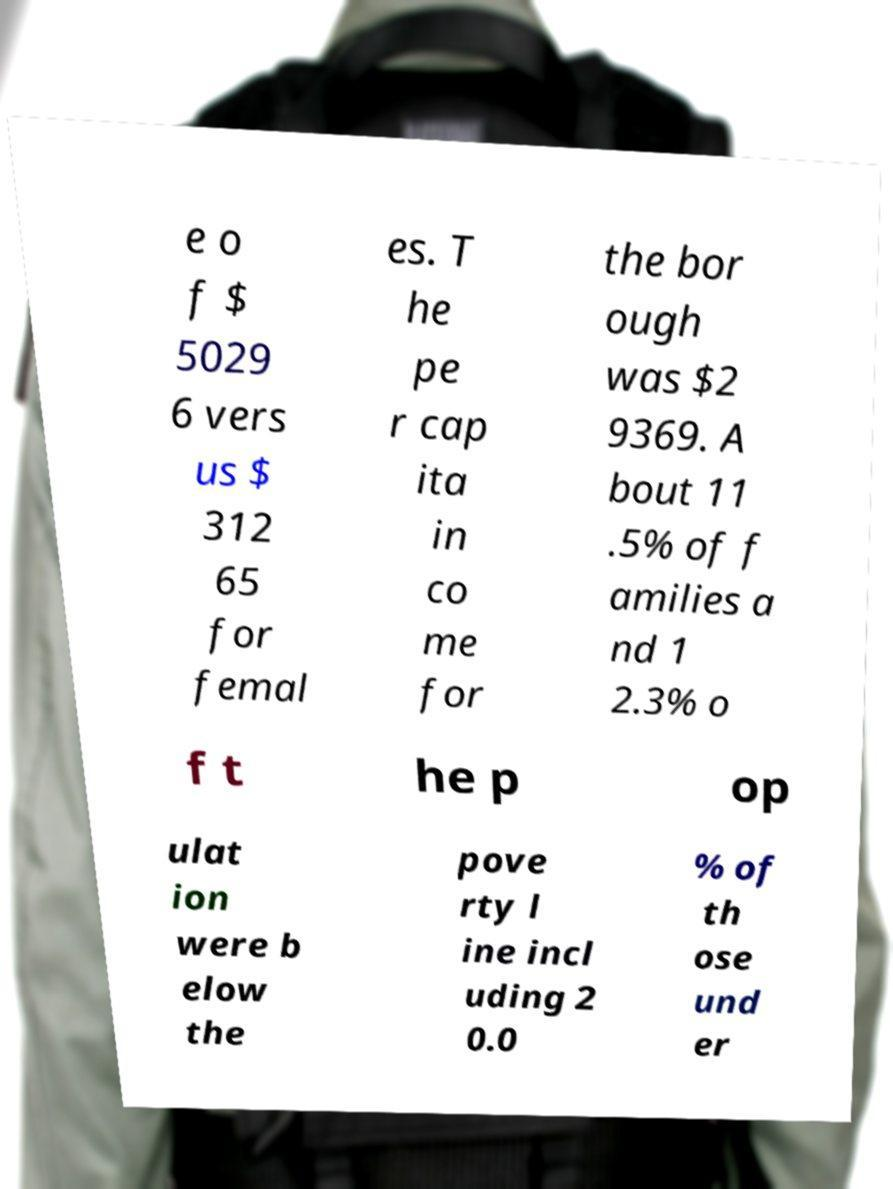Could you extract and type out the text from this image? e o f $ 5029 6 vers us $ 312 65 for femal es. T he pe r cap ita in co me for the bor ough was $2 9369. A bout 11 .5% of f amilies a nd 1 2.3% o f t he p op ulat ion were b elow the pove rty l ine incl uding 2 0.0 % of th ose und er 